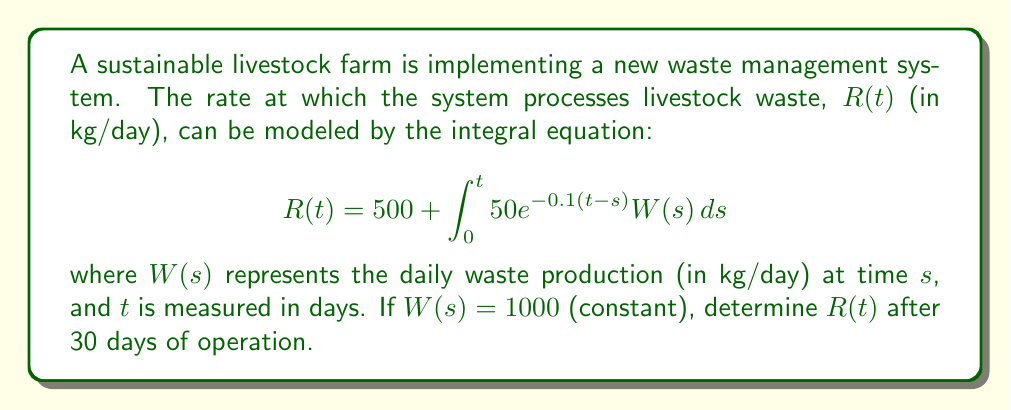Could you help me with this problem? Let's solve this step-by-step:

1) We start with the given integral equation:
   $$R(t) = 500 + \int_0^t 50e^{-0.1(t-s)}W(s)ds$$

2) We're told that $W(s) = 1000$ (constant), so we can substitute this:
   $$R(t) = 500 + \int_0^t 50e^{-0.1(t-s)} \cdot 1000 \, ds$$

3) Simplify the constant:
   $$R(t) = 500 + 50000 \int_0^t e^{-0.1(t-s)} \, ds$$

4) To solve this, let's use the substitution $u = t-s$, so $du = -ds$:
   $$R(t) = 500 - 50000 \int_t^0 e^{-0.1u} \, du$$

5) Adjust the limits of integration:
   $$R(t) = 500 + 50000 \int_0^t e^{-0.1u} \, du$$

6) Integrate:
   $$R(t) = 500 + 50000 \left[-10e^{-0.1u}\right]_0^t$$

7) Evaluate the integral:
   $$R(t) = 500 + 50000 \left(-10e^{-0.1t} + 10\right)$$

8) Simplify:
   $$R(t) = 500 + 500000 - 500000e^{-0.1t}$$
   $$R(t) = 500500 - 500000e^{-0.1t}$$

9) Now, we need to find $R(30)$:
   $$R(30) = 500500 - 500000e^{-0.1(30)}$$
   $$R(30) = 500500 - 500000e^{-3}$$

10) Calculate the final value:
    $$R(30) \approx 500500 - 24930 \approx 475570$$

Therefore, after 30 days of operation, the system will be processing approximately 475,570 kg of waste per day.
Answer: 475,570 kg/day 